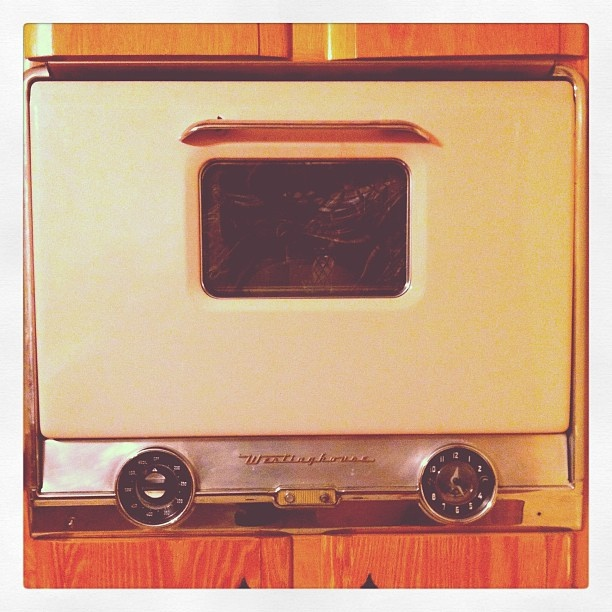Describe the objects in this image and their specific colors. I can see a oven in white, tan, and brown tones in this image. 